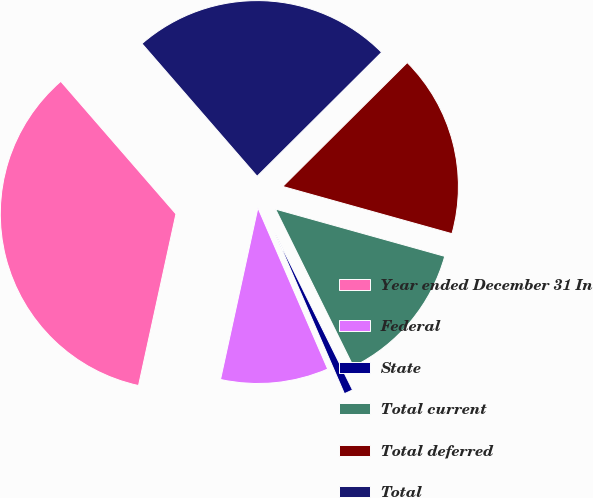Convert chart to OTSL. <chart><loc_0><loc_0><loc_500><loc_500><pie_chart><fcel>Year ended December 31 In<fcel>Federal<fcel>State<fcel>Total current<fcel>Total deferred<fcel>Total<nl><fcel>35.21%<fcel>9.92%<fcel>0.81%<fcel>13.36%<fcel>16.8%<fcel>23.92%<nl></chart> 